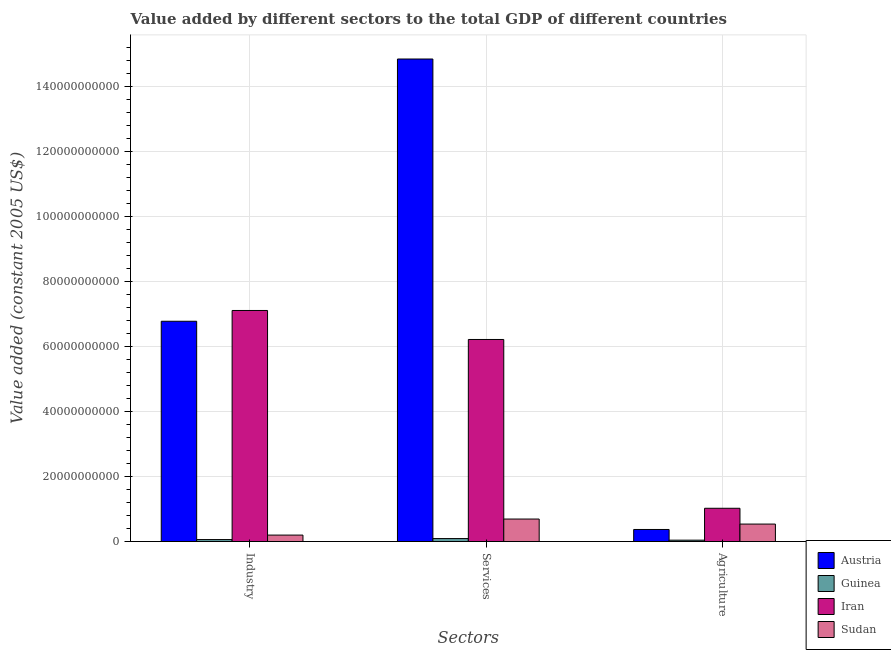How many different coloured bars are there?
Offer a terse response. 4. How many groups of bars are there?
Offer a very short reply. 3. Are the number of bars per tick equal to the number of legend labels?
Offer a very short reply. Yes. Are the number of bars on each tick of the X-axis equal?
Make the answer very short. Yes. How many bars are there on the 2nd tick from the left?
Provide a short and direct response. 4. How many bars are there on the 2nd tick from the right?
Ensure brevity in your answer.  4. What is the label of the 3rd group of bars from the left?
Your response must be concise. Agriculture. What is the value added by industrial sector in Sudan?
Ensure brevity in your answer.  1.99e+09. Across all countries, what is the maximum value added by agricultural sector?
Make the answer very short. 1.02e+1. Across all countries, what is the minimum value added by industrial sector?
Make the answer very short. 6.14e+08. In which country was the value added by services maximum?
Ensure brevity in your answer.  Austria. In which country was the value added by industrial sector minimum?
Your response must be concise. Guinea. What is the total value added by industrial sector in the graph?
Your answer should be compact. 1.41e+11. What is the difference between the value added by industrial sector in Austria and that in Guinea?
Your response must be concise. 6.71e+1. What is the difference between the value added by agricultural sector in Iran and the value added by services in Austria?
Provide a succinct answer. -1.38e+11. What is the average value added by agricultural sector per country?
Offer a very short reply. 4.94e+09. What is the difference between the value added by services and value added by industrial sector in Austria?
Keep it short and to the point. 8.07e+1. What is the ratio of the value added by agricultural sector in Guinea to that in Iran?
Offer a terse response. 0.04. Is the value added by industrial sector in Sudan less than that in Iran?
Your answer should be very brief. Yes. Is the difference between the value added by agricultural sector in Sudan and Iran greater than the difference between the value added by services in Sudan and Iran?
Make the answer very short. Yes. What is the difference between the highest and the second highest value added by agricultural sector?
Ensure brevity in your answer.  4.86e+09. What is the difference between the highest and the lowest value added by industrial sector?
Offer a very short reply. 7.05e+1. Is the sum of the value added by services in Guinea and Austria greater than the maximum value added by agricultural sector across all countries?
Your answer should be compact. Yes. What does the 2nd bar from the left in Industry represents?
Make the answer very short. Guinea. What does the 3rd bar from the right in Industry represents?
Your response must be concise. Guinea. How many bars are there?
Your answer should be very brief. 12. Are all the bars in the graph horizontal?
Ensure brevity in your answer.  No. How many countries are there in the graph?
Offer a very short reply. 4. Does the graph contain grids?
Make the answer very short. Yes. Where does the legend appear in the graph?
Offer a terse response. Bottom right. How many legend labels are there?
Offer a very short reply. 4. What is the title of the graph?
Offer a very short reply. Value added by different sectors to the total GDP of different countries. Does "Macao" appear as one of the legend labels in the graph?
Your answer should be compact. No. What is the label or title of the X-axis?
Provide a succinct answer. Sectors. What is the label or title of the Y-axis?
Your answer should be compact. Value added (constant 2005 US$). What is the Value added (constant 2005 US$) in Austria in Industry?
Provide a short and direct response. 6.78e+1. What is the Value added (constant 2005 US$) of Guinea in Industry?
Your answer should be very brief. 6.14e+08. What is the Value added (constant 2005 US$) of Iran in Industry?
Your answer should be compact. 7.11e+1. What is the Value added (constant 2005 US$) in Sudan in Industry?
Offer a terse response. 1.99e+09. What is the Value added (constant 2005 US$) of Austria in Services?
Your answer should be very brief. 1.48e+11. What is the Value added (constant 2005 US$) in Guinea in Services?
Ensure brevity in your answer.  9.18e+08. What is the Value added (constant 2005 US$) of Iran in Services?
Give a very brief answer. 6.21e+1. What is the Value added (constant 2005 US$) of Sudan in Services?
Provide a succinct answer. 6.93e+09. What is the Value added (constant 2005 US$) in Austria in Agriculture?
Ensure brevity in your answer.  3.72e+09. What is the Value added (constant 2005 US$) in Guinea in Agriculture?
Your response must be concise. 4.29e+08. What is the Value added (constant 2005 US$) in Iran in Agriculture?
Offer a terse response. 1.02e+1. What is the Value added (constant 2005 US$) in Sudan in Agriculture?
Keep it short and to the point. 5.38e+09. Across all Sectors, what is the maximum Value added (constant 2005 US$) in Austria?
Your answer should be compact. 1.48e+11. Across all Sectors, what is the maximum Value added (constant 2005 US$) in Guinea?
Your answer should be compact. 9.18e+08. Across all Sectors, what is the maximum Value added (constant 2005 US$) of Iran?
Your answer should be very brief. 7.11e+1. Across all Sectors, what is the maximum Value added (constant 2005 US$) of Sudan?
Ensure brevity in your answer.  6.93e+09. Across all Sectors, what is the minimum Value added (constant 2005 US$) of Austria?
Your answer should be compact. 3.72e+09. Across all Sectors, what is the minimum Value added (constant 2005 US$) in Guinea?
Provide a short and direct response. 4.29e+08. Across all Sectors, what is the minimum Value added (constant 2005 US$) in Iran?
Your response must be concise. 1.02e+1. Across all Sectors, what is the minimum Value added (constant 2005 US$) in Sudan?
Provide a short and direct response. 1.99e+09. What is the total Value added (constant 2005 US$) in Austria in the graph?
Offer a very short reply. 2.20e+11. What is the total Value added (constant 2005 US$) of Guinea in the graph?
Provide a short and direct response. 1.96e+09. What is the total Value added (constant 2005 US$) of Iran in the graph?
Make the answer very short. 1.43e+11. What is the total Value added (constant 2005 US$) of Sudan in the graph?
Provide a succinct answer. 1.43e+1. What is the difference between the Value added (constant 2005 US$) of Austria in Industry and that in Services?
Offer a very short reply. -8.07e+1. What is the difference between the Value added (constant 2005 US$) in Guinea in Industry and that in Services?
Provide a succinct answer. -3.04e+08. What is the difference between the Value added (constant 2005 US$) of Iran in Industry and that in Services?
Your response must be concise. 8.92e+09. What is the difference between the Value added (constant 2005 US$) in Sudan in Industry and that in Services?
Offer a terse response. -4.93e+09. What is the difference between the Value added (constant 2005 US$) of Austria in Industry and that in Agriculture?
Provide a succinct answer. 6.40e+1. What is the difference between the Value added (constant 2005 US$) of Guinea in Industry and that in Agriculture?
Ensure brevity in your answer.  1.85e+08. What is the difference between the Value added (constant 2005 US$) in Iran in Industry and that in Agriculture?
Your answer should be compact. 6.08e+1. What is the difference between the Value added (constant 2005 US$) in Sudan in Industry and that in Agriculture?
Offer a terse response. -3.39e+09. What is the difference between the Value added (constant 2005 US$) in Austria in Services and that in Agriculture?
Ensure brevity in your answer.  1.45e+11. What is the difference between the Value added (constant 2005 US$) of Guinea in Services and that in Agriculture?
Ensure brevity in your answer.  4.89e+08. What is the difference between the Value added (constant 2005 US$) in Iran in Services and that in Agriculture?
Make the answer very short. 5.19e+1. What is the difference between the Value added (constant 2005 US$) of Sudan in Services and that in Agriculture?
Provide a succinct answer. 1.55e+09. What is the difference between the Value added (constant 2005 US$) in Austria in Industry and the Value added (constant 2005 US$) in Guinea in Services?
Provide a short and direct response. 6.68e+1. What is the difference between the Value added (constant 2005 US$) in Austria in Industry and the Value added (constant 2005 US$) in Iran in Services?
Offer a very short reply. 5.60e+09. What is the difference between the Value added (constant 2005 US$) of Austria in Industry and the Value added (constant 2005 US$) of Sudan in Services?
Offer a very short reply. 6.08e+1. What is the difference between the Value added (constant 2005 US$) of Guinea in Industry and the Value added (constant 2005 US$) of Iran in Services?
Provide a short and direct response. -6.15e+1. What is the difference between the Value added (constant 2005 US$) of Guinea in Industry and the Value added (constant 2005 US$) of Sudan in Services?
Provide a succinct answer. -6.31e+09. What is the difference between the Value added (constant 2005 US$) of Iran in Industry and the Value added (constant 2005 US$) of Sudan in Services?
Give a very brief answer. 6.41e+1. What is the difference between the Value added (constant 2005 US$) in Austria in Industry and the Value added (constant 2005 US$) in Guinea in Agriculture?
Provide a succinct answer. 6.73e+1. What is the difference between the Value added (constant 2005 US$) in Austria in Industry and the Value added (constant 2005 US$) in Iran in Agriculture?
Make the answer very short. 5.75e+1. What is the difference between the Value added (constant 2005 US$) in Austria in Industry and the Value added (constant 2005 US$) in Sudan in Agriculture?
Your answer should be very brief. 6.24e+1. What is the difference between the Value added (constant 2005 US$) in Guinea in Industry and the Value added (constant 2005 US$) in Iran in Agriculture?
Provide a short and direct response. -9.62e+09. What is the difference between the Value added (constant 2005 US$) of Guinea in Industry and the Value added (constant 2005 US$) of Sudan in Agriculture?
Provide a succinct answer. -4.77e+09. What is the difference between the Value added (constant 2005 US$) of Iran in Industry and the Value added (constant 2005 US$) of Sudan in Agriculture?
Your answer should be compact. 6.57e+1. What is the difference between the Value added (constant 2005 US$) in Austria in Services and the Value added (constant 2005 US$) in Guinea in Agriculture?
Your answer should be very brief. 1.48e+11. What is the difference between the Value added (constant 2005 US$) in Austria in Services and the Value added (constant 2005 US$) in Iran in Agriculture?
Your answer should be compact. 1.38e+11. What is the difference between the Value added (constant 2005 US$) of Austria in Services and the Value added (constant 2005 US$) of Sudan in Agriculture?
Make the answer very short. 1.43e+11. What is the difference between the Value added (constant 2005 US$) in Guinea in Services and the Value added (constant 2005 US$) in Iran in Agriculture?
Your answer should be very brief. -9.32e+09. What is the difference between the Value added (constant 2005 US$) in Guinea in Services and the Value added (constant 2005 US$) in Sudan in Agriculture?
Offer a terse response. -4.46e+09. What is the difference between the Value added (constant 2005 US$) of Iran in Services and the Value added (constant 2005 US$) of Sudan in Agriculture?
Offer a terse response. 5.68e+1. What is the average Value added (constant 2005 US$) in Austria per Sectors?
Provide a short and direct response. 7.33e+1. What is the average Value added (constant 2005 US$) of Guinea per Sectors?
Your answer should be compact. 6.54e+08. What is the average Value added (constant 2005 US$) of Iran per Sectors?
Your answer should be compact. 4.78e+1. What is the average Value added (constant 2005 US$) of Sudan per Sectors?
Make the answer very short. 4.77e+09. What is the difference between the Value added (constant 2005 US$) in Austria and Value added (constant 2005 US$) in Guinea in Industry?
Your answer should be very brief. 6.71e+1. What is the difference between the Value added (constant 2005 US$) of Austria and Value added (constant 2005 US$) of Iran in Industry?
Give a very brief answer. -3.32e+09. What is the difference between the Value added (constant 2005 US$) in Austria and Value added (constant 2005 US$) in Sudan in Industry?
Your response must be concise. 6.58e+1. What is the difference between the Value added (constant 2005 US$) of Guinea and Value added (constant 2005 US$) of Iran in Industry?
Offer a terse response. -7.05e+1. What is the difference between the Value added (constant 2005 US$) in Guinea and Value added (constant 2005 US$) in Sudan in Industry?
Your answer should be compact. -1.38e+09. What is the difference between the Value added (constant 2005 US$) of Iran and Value added (constant 2005 US$) of Sudan in Industry?
Keep it short and to the point. 6.91e+1. What is the difference between the Value added (constant 2005 US$) in Austria and Value added (constant 2005 US$) in Guinea in Services?
Your answer should be very brief. 1.47e+11. What is the difference between the Value added (constant 2005 US$) in Austria and Value added (constant 2005 US$) in Iran in Services?
Ensure brevity in your answer.  8.63e+1. What is the difference between the Value added (constant 2005 US$) in Austria and Value added (constant 2005 US$) in Sudan in Services?
Your answer should be very brief. 1.41e+11. What is the difference between the Value added (constant 2005 US$) in Guinea and Value added (constant 2005 US$) in Iran in Services?
Offer a very short reply. -6.12e+1. What is the difference between the Value added (constant 2005 US$) of Guinea and Value added (constant 2005 US$) of Sudan in Services?
Your answer should be very brief. -6.01e+09. What is the difference between the Value added (constant 2005 US$) of Iran and Value added (constant 2005 US$) of Sudan in Services?
Your answer should be very brief. 5.52e+1. What is the difference between the Value added (constant 2005 US$) in Austria and Value added (constant 2005 US$) in Guinea in Agriculture?
Make the answer very short. 3.29e+09. What is the difference between the Value added (constant 2005 US$) of Austria and Value added (constant 2005 US$) of Iran in Agriculture?
Your answer should be compact. -6.52e+09. What is the difference between the Value added (constant 2005 US$) in Austria and Value added (constant 2005 US$) in Sudan in Agriculture?
Your answer should be very brief. -1.67e+09. What is the difference between the Value added (constant 2005 US$) in Guinea and Value added (constant 2005 US$) in Iran in Agriculture?
Ensure brevity in your answer.  -9.81e+09. What is the difference between the Value added (constant 2005 US$) in Guinea and Value added (constant 2005 US$) in Sudan in Agriculture?
Offer a terse response. -4.95e+09. What is the difference between the Value added (constant 2005 US$) of Iran and Value added (constant 2005 US$) of Sudan in Agriculture?
Provide a succinct answer. 4.86e+09. What is the ratio of the Value added (constant 2005 US$) of Austria in Industry to that in Services?
Make the answer very short. 0.46. What is the ratio of the Value added (constant 2005 US$) of Guinea in Industry to that in Services?
Ensure brevity in your answer.  0.67. What is the ratio of the Value added (constant 2005 US$) in Iran in Industry to that in Services?
Provide a succinct answer. 1.14. What is the ratio of the Value added (constant 2005 US$) in Sudan in Industry to that in Services?
Offer a very short reply. 0.29. What is the ratio of the Value added (constant 2005 US$) in Austria in Industry to that in Agriculture?
Your response must be concise. 18.24. What is the ratio of the Value added (constant 2005 US$) in Guinea in Industry to that in Agriculture?
Provide a short and direct response. 1.43. What is the ratio of the Value added (constant 2005 US$) in Iran in Industry to that in Agriculture?
Give a very brief answer. 6.94. What is the ratio of the Value added (constant 2005 US$) in Sudan in Industry to that in Agriculture?
Your answer should be compact. 0.37. What is the ratio of the Value added (constant 2005 US$) in Austria in Services to that in Agriculture?
Make the answer very short. 39.94. What is the ratio of the Value added (constant 2005 US$) of Guinea in Services to that in Agriculture?
Your answer should be compact. 2.14. What is the ratio of the Value added (constant 2005 US$) in Iran in Services to that in Agriculture?
Give a very brief answer. 6.07. What is the ratio of the Value added (constant 2005 US$) in Sudan in Services to that in Agriculture?
Provide a short and direct response. 1.29. What is the difference between the highest and the second highest Value added (constant 2005 US$) in Austria?
Your answer should be very brief. 8.07e+1. What is the difference between the highest and the second highest Value added (constant 2005 US$) in Guinea?
Make the answer very short. 3.04e+08. What is the difference between the highest and the second highest Value added (constant 2005 US$) in Iran?
Provide a short and direct response. 8.92e+09. What is the difference between the highest and the second highest Value added (constant 2005 US$) of Sudan?
Ensure brevity in your answer.  1.55e+09. What is the difference between the highest and the lowest Value added (constant 2005 US$) in Austria?
Make the answer very short. 1.45e+11. What is the difference between the highest and the lowest Value added (constant 2005 US$) in Guinea?
Ensure brevity in your answer.  4.89e+08. What is the difference between the highest and the lowest Value added (constant 2005 US$) of Iran?
Your response must be concise. 6.08e+1. What is the difference between the highest and the lowest Value added (constant 2005 US$) of Sudan?
Make the answer very short. 4.93e+09. 